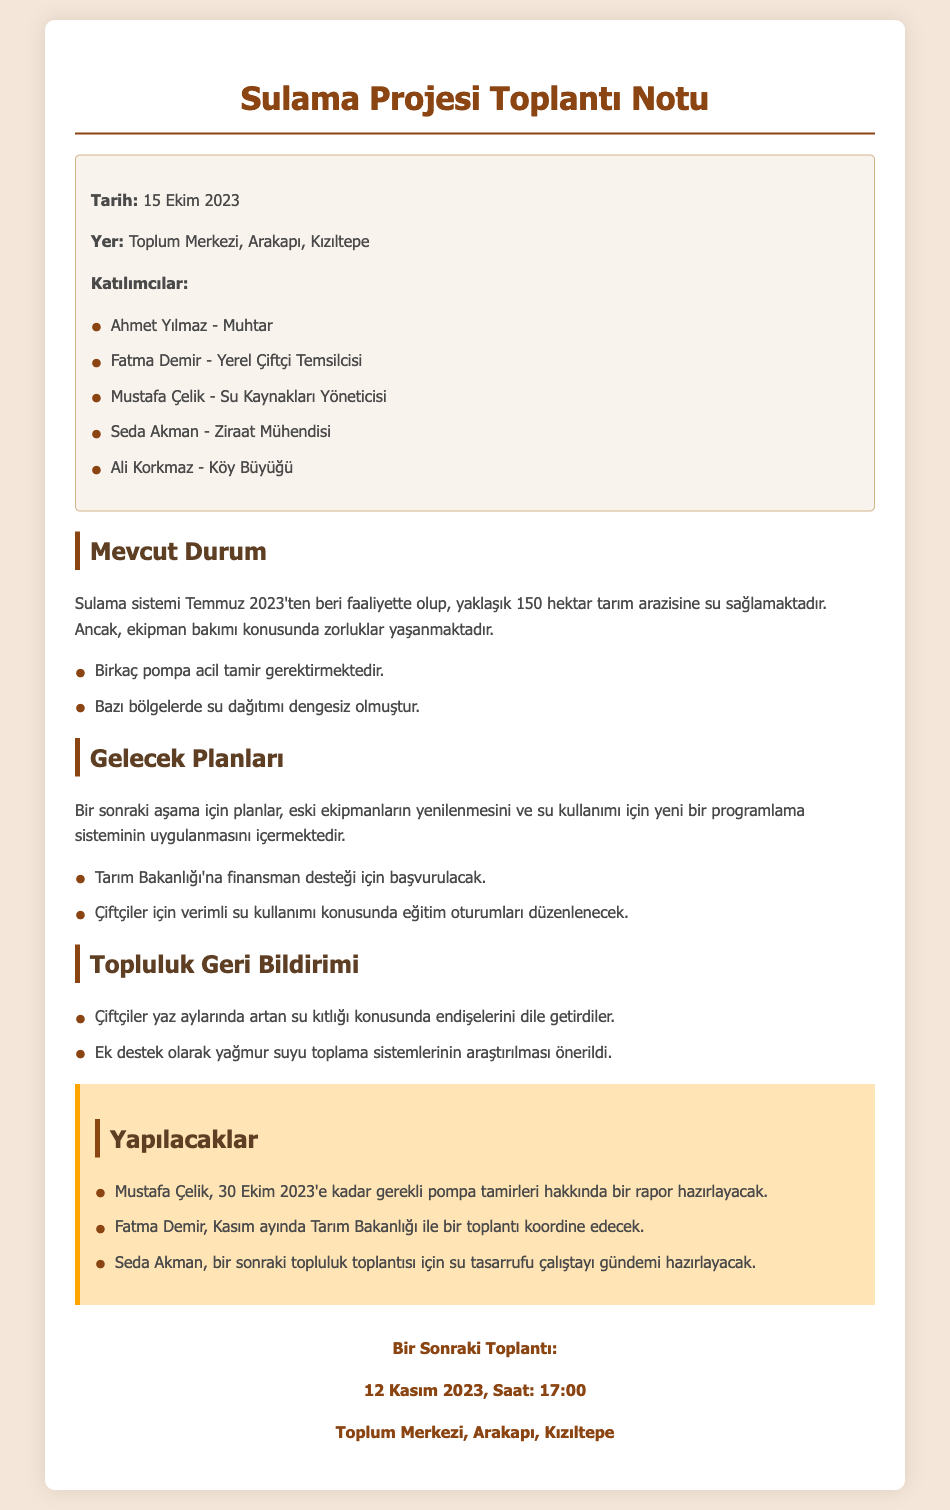Tarih nedir? Tarih, toplantının yapıldığı tarihi belirtir. Toplantı 15 Ekim 2023 tarihinde gerçekleştirilmiştir.
Answer: 15 Ekim 2023 Toplantı nerede yapıldı? Toplantının gerçekleştiği yer, belgenin üst kısmında belirtilmiştir. Toplantı Toplum Merkezi, Arakapı, Kızıltepe'de yapılmıştır.
Answer: Toplum Merkezi, Arakapı, Kızıltepe Kimler katıldı? Katılımcılar listesi, belgenin içeriğinde verilmiştir. Katılımcılar arasında Ahmet Yılmaz, Fatma Demir, Mustafa Çelik, Seda Akman ve Ali Korkmaz bulunmaktadır.
Answer: Ahmet Yılmaz, Fatma Demir, Mustafa Çelik, Seda Akman, Ali Korkmaz Sulama sistemi ne zaman faaliyete geçti? Sulama sisteminin faaliyete geçiş tarihi, belgedeki mevcut durum kısmında belirtilmiştir. Sulama sistemi Temmuz 2023'ten beri faaliyette.
Answer: Temmuz 2023 Ne gibi sorunlar var? Problemler, belgenin mevcut durum bölümünde açıklanmıştır. Ekipman bakımı konusunda zorluklar yaşanmaktadır ve bazı pompaların acil tamir gerektirmesi sorunların başındadır.
Answer: Ekipman bakımı, pompalar Gelecek planları neler? Gelecek planları, belgede belirli bir bölüm ile açıklanmaktadır. Eski ekipmanların yenilenmesi ve yeni bir su kullanımı programı uygulanması planlanmaktadır.
Answer: Eski ekipmanların yenilenmesi, yeni bir program Yapılacaklar arasında kim ne yapacak? Belgede belirtilen görevler, her katılımcıya göre ayrıştırılmıştır. Mustafa Çelik, pompa tamirleri hakkında rapor hazırlayacak.
Answer: Mustafa Çelik Bir sonraki toplantı tarihi nedir? Bir sonraki toplantının tarihi, belgenin en alt kısmında yer alır. Bir sonraki toplantı 12 Kasım 2023 tarihinde yapılacak.
Answer: 12 Kasım 2023 